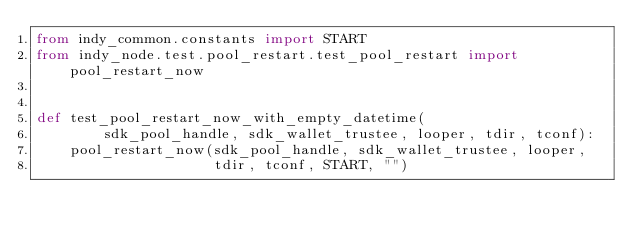<code> <loc_0><loc_0><loc_500><loc_500><_Python_>from indy_common.constants import START
from indy_node.test.pool_restart.test_pool_restart import pool_restart_now


def test_pool_restart_now_with_empty_datetime(
        sdk_pool_handle, sdk_wallet_trustee, looper, tdir, tconf):
    pool_restart_now(sdk_pool_handle, sdk_wallet_trustee, looper,
                     tdir, tconf, START, "")</code> 